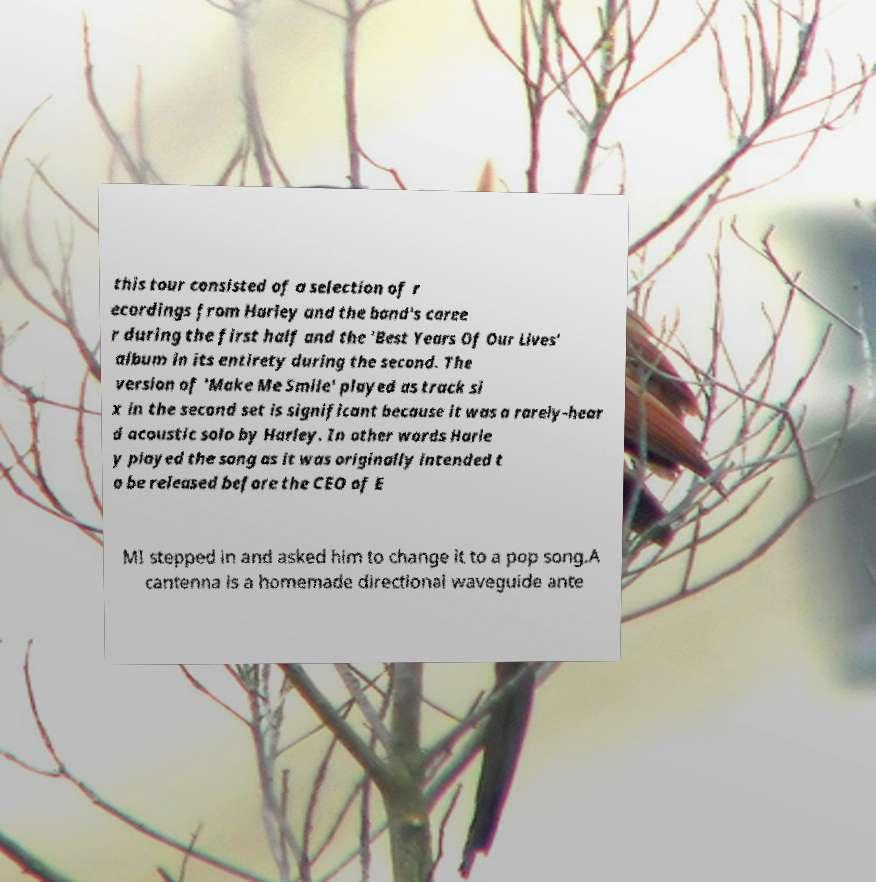There's text embedded in this image that I need extracted. Can you transcribe it verbatim? this tour consisted of a selection of r ecordings from Harley and the band's caree r during the first half and the 'Best Years Of Our Lives' album in its entirety during the second. The version of 'Make Me Smile' played as track si x in the second set is significant because it was a rarely-hear d acoustic solo by Harley. In other words Harle y played the song as it was originally intended t o be released before the CEO of E MI stepped in and asked him to change it to a pop song.A cantenna is a homemade directional waveguide ante 